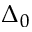<formula> <loc_0><loc_0><loc_500><loc_500>\Delta _ { 0 }</formula> 